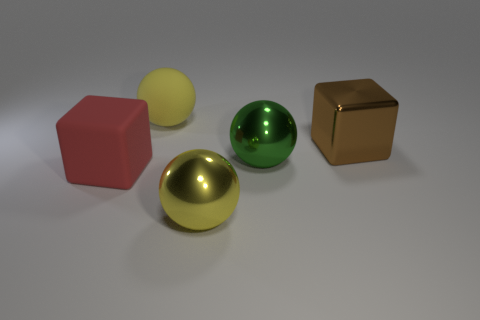Are the object that is behind the brown thing and the yellow object that is in front of the brown metal cube made of the same material?
Provide a short and direct response. No. There is a block right of the yellow shiny thing; is there a block on the left side of it?
Make the answer very short. Yes. There is a sphere that is made of the same material as the red block; what color is it?
Provide a short and direct response. Yellow. Are there more green metal spheres than big metal things?
Offer a very short reply. No. How many objects are either big yellow spheres right of the big rubber ball or small gray blocks?
Your response must be concise. 1. Are there any spheres that have the same size as the brown metallic cube?
Your answer should be very brief. Yes. Are there fewer brown metallic objects than tiny yellow balls?
Ensure brevity in your answer.  No. What number of balls are either red matte objects or large yellow matte objects?
Provide a succinct answer. 1. How many big metallic spheres have the same color as the matte ball?
Keep it short and to the point. 1. What is the size of the object that is both right of the big red cube and in front of the green metal sphere?
Offer a very short reply. Large. 